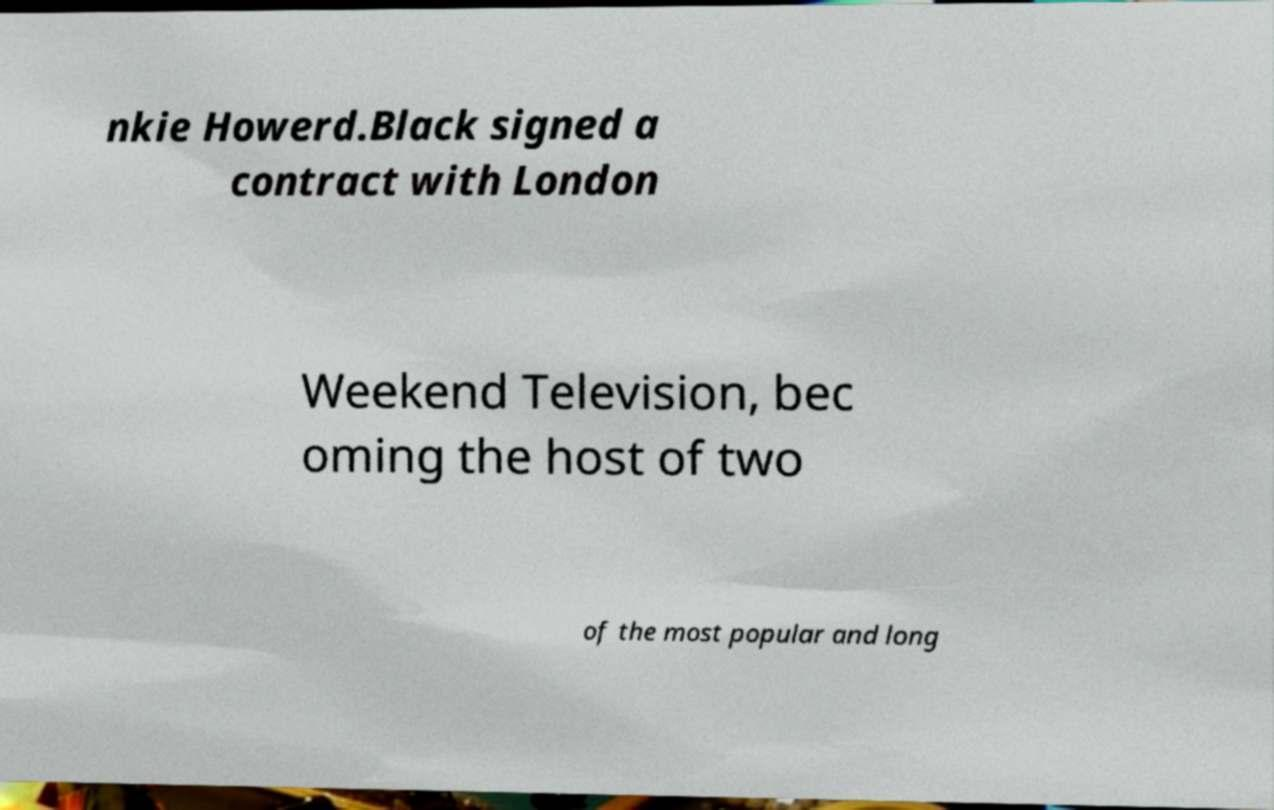There's text embedded in this image that I need extracted. Can you transcribe it verbatim? nkie Howerd.Black signed a contract with London Weekend Television, bec oming the host of two of the most popular and long 